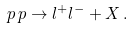Convert formula to latex. <formula><loc_0><loc_0><loc_500><loc_500>p \, p \rightarrow l ^ { + } l ^ { - } + X \, .</formula> 